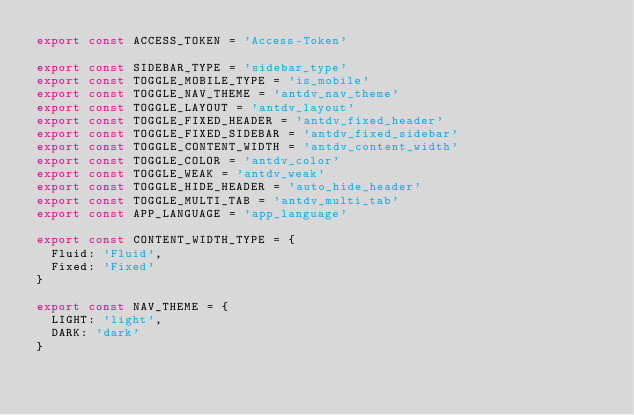Convert code to text. <code><loc_0><loc_0><loc_500><loc_500><_JavaScript_>export const ACCESS_TOKEN = 'Access-Token'

export const SIDEBAR_TYPE = 'sidebar_type'
export const TOGGLE_MOBILE_TYPE = 'is_mobile'
export const TOGGLE_NAV_THEME = 'antdv_nav_theme'
export const TOGGLE_LAYOUT = 'antdv_layout'
export const TOGGLE_FIXED_HEADER = 'antdv_fixed_header'
export const TOGGLE_FIXED_SIDEBAR = 'antdv_fixed_sidebar'
export const TOGGLE_CONTENT_WIDTH = 'antdv_content_width'
export const TOGGLE_COLOR = 'antdv_color'
export const TOGGLE_WEAK = 'antdv_weak'
export const TOGGLE_HIDE_HEADER = 'auto_hide_header'
export const TOGGLE_MULTI_TAB = 'antdv_multi_tab'
export const APP_LANGUAGE = 'app_language'

export const CONTENT_WIDTH_TYPE = {
  Fluid: 'Fluid',
  Fixed: 'Fixed'
}

export const NAV_THEME = {
  LIGHT: 'light',
  DARK: 'dark'
}
</code> 